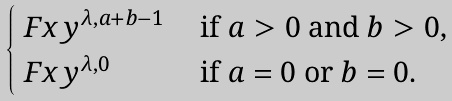Convert formula to latex. <formula><loc_0><loc_0><loc_500><loc_500>\begin{cases} \ F x y ^ { \lambda , a + b - 1 } & \text { if $a>0$ and $b>0$,} \\ \ F x y ^ { \lambda , 0 } & \text { if $a=0$ or $b=0$.} \end{cases}</formula> 